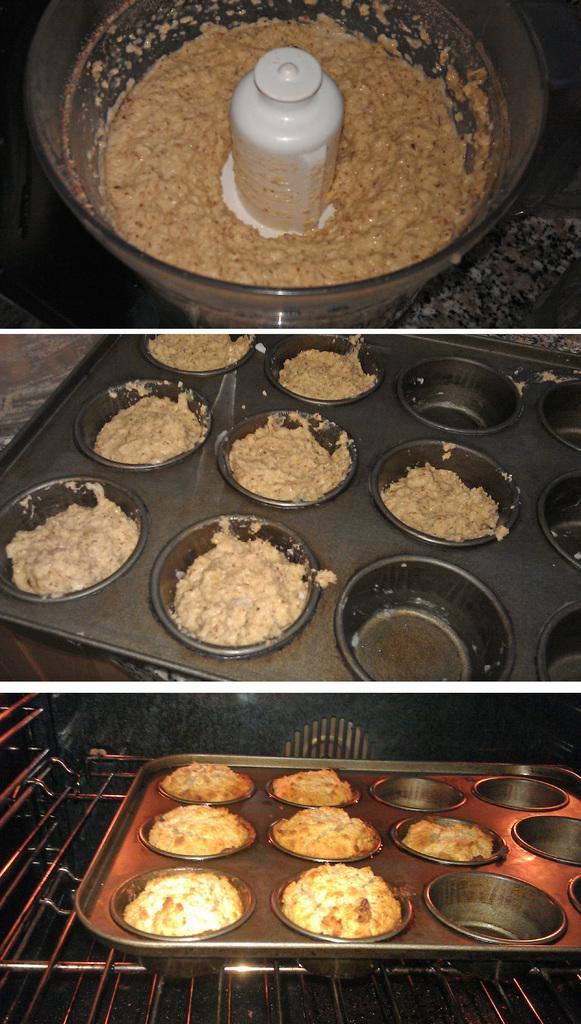How would you summarize this image in a sentence or two? In this image we can see a collage images of a food. 